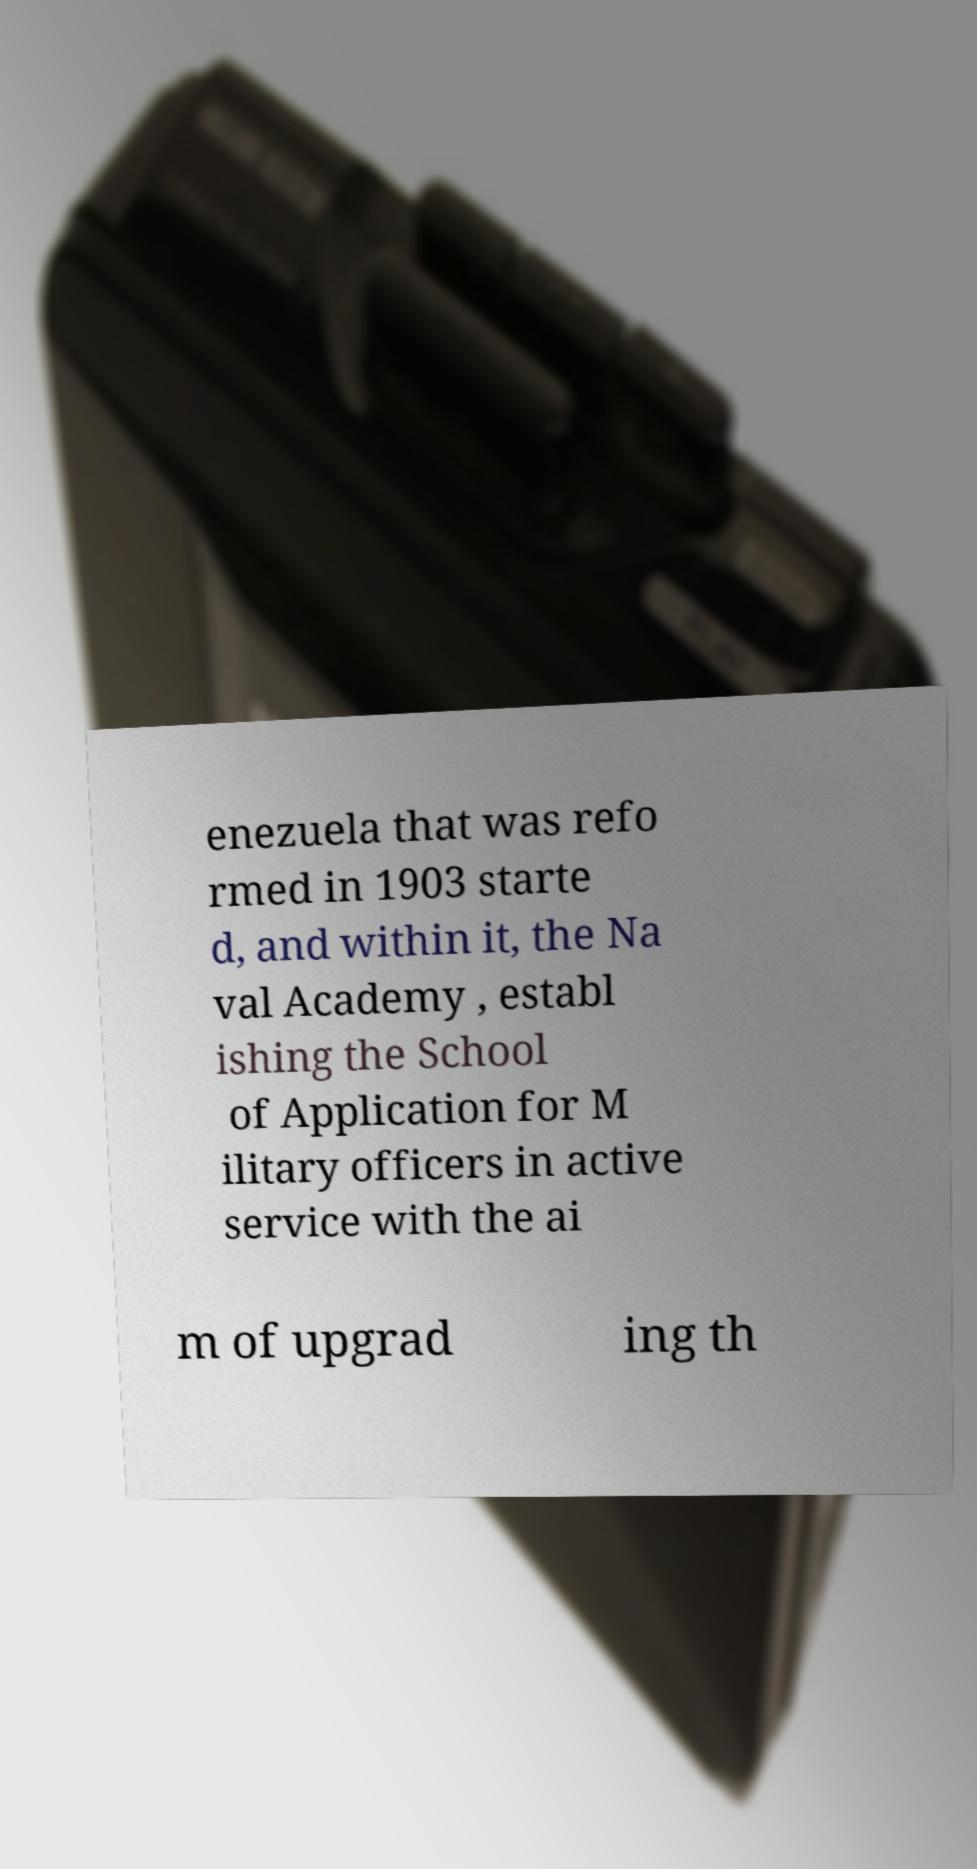Could you extract and type out the text from this image? enezuela that was refo rmed in 1903 starte d, and within it, the Na val Academy , establ ishing the School of Application for M ilitary officers in active service with the ai m of upgrad ing th 